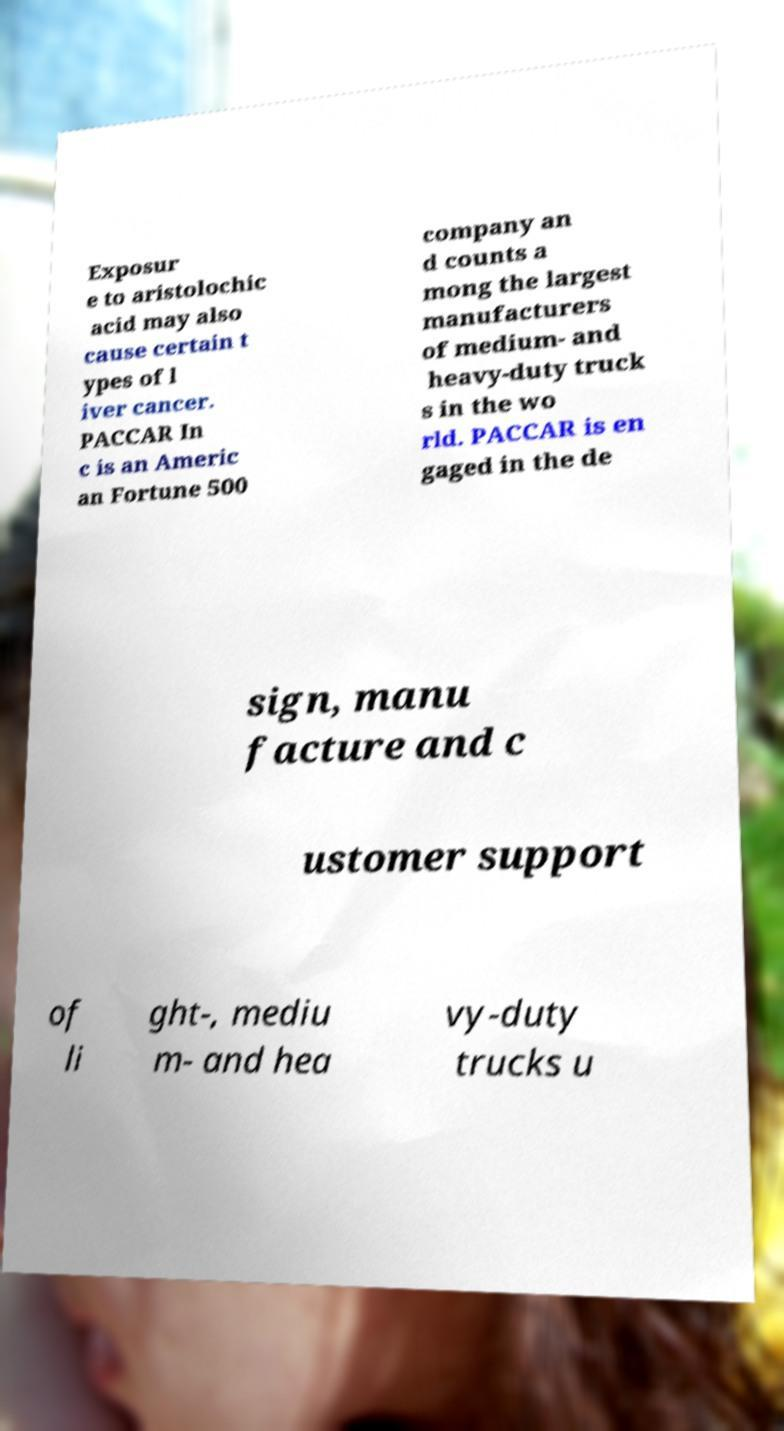I need the written content from this picture converted into text. Can you do that? Exposur e to aristolochic acid may also cause certain t ypes of l iver cancer. PACCAR In c is an Americ an Fortune 500 company an d counts a mong the largest manufacturers of medium- and heavy-duty truck s in the wo rld. PACCAR is en gaged in the de sign, manu facture and c ustomer support of li ght-, mediu m- and hea vy-duty trucks u 